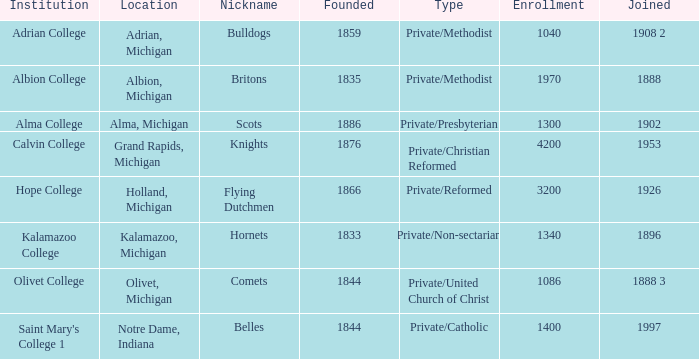How many organizations came into existence in the year 1833? 1.0. 